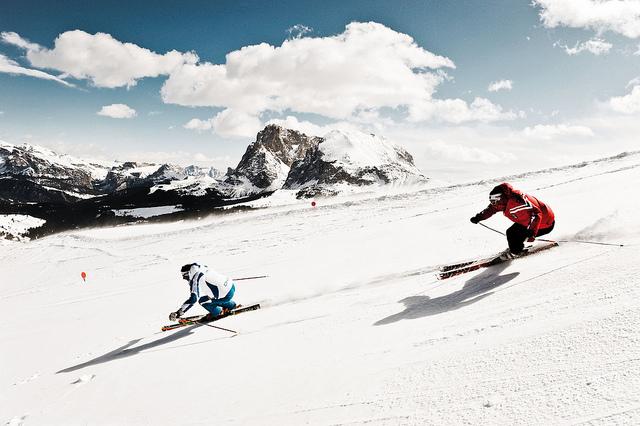Which skier is ahead?
Keep it brief. White jacket. Is he cashing someone?
Give a very brief answer. No. Are the skiers going up hill?
Concise answer only. No. Are there any clouds in the sky?
Concise answer only. Yes. Why is it snow on the ground?
Quick response, please. Winter. 